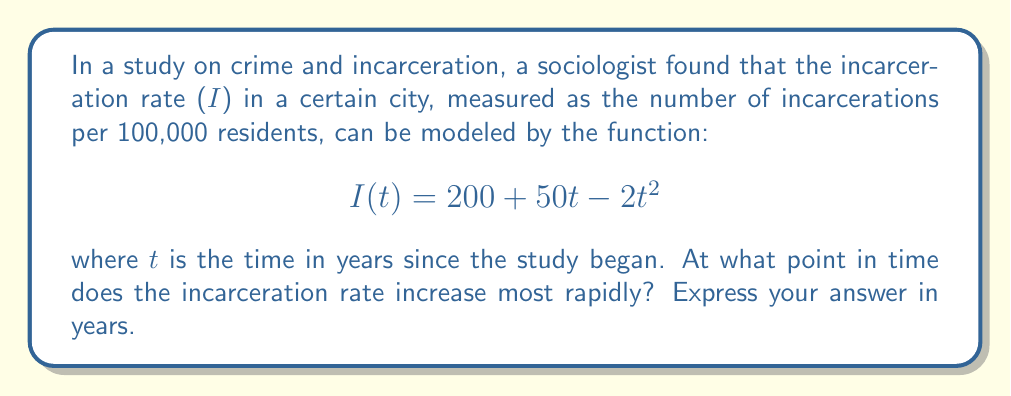Provide a solution to this math problem. To find the point at which the incarceration rate increases most rapidly, we need to find the maximum value of the derivative of I(t).

Step 1: Find the first derivative of I(t).
$$I'(t) = 50 - 4t$$

Step 2: To find the maximum rate of increase, we need to find where the second derivative equals zero.
$$I''(t) = -4$$

The second derivative is constant and negative, which means the first derivative has a maximum value at its only critical point.

Step 3: Set the first derivative equal to zero and solve for t.
$$50 - 4t = 0$$
$$-4t = -50$$
$$t = \frac{50}{4} = 12.5$$

Step 4: Verify that this is indeed a maximum by checking the sign of the second derivative.
Since $I''(t) = -4 < 0$ for all t, the critical point at t = 12.5 years is a maximum.

Therefore, the incarceration rate increases most rapidly at t = 12.5 years after the study began.
Answer: 12.5 years 